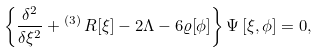Convert formula to latex. <formula><loc_0><loc_0><loc_500><loc_500>\left \{ \frac { \delta ^ { 2 } } { \delta { \xi ^ { 2 } } } + { ^ { ( 3 ) } \, R [ \xi ] } - 2 \Lambda - 6 \varrho [ \phi ] \right \} \Psi \left [ \xi , \phi \right ] = 0 ,</formula> 